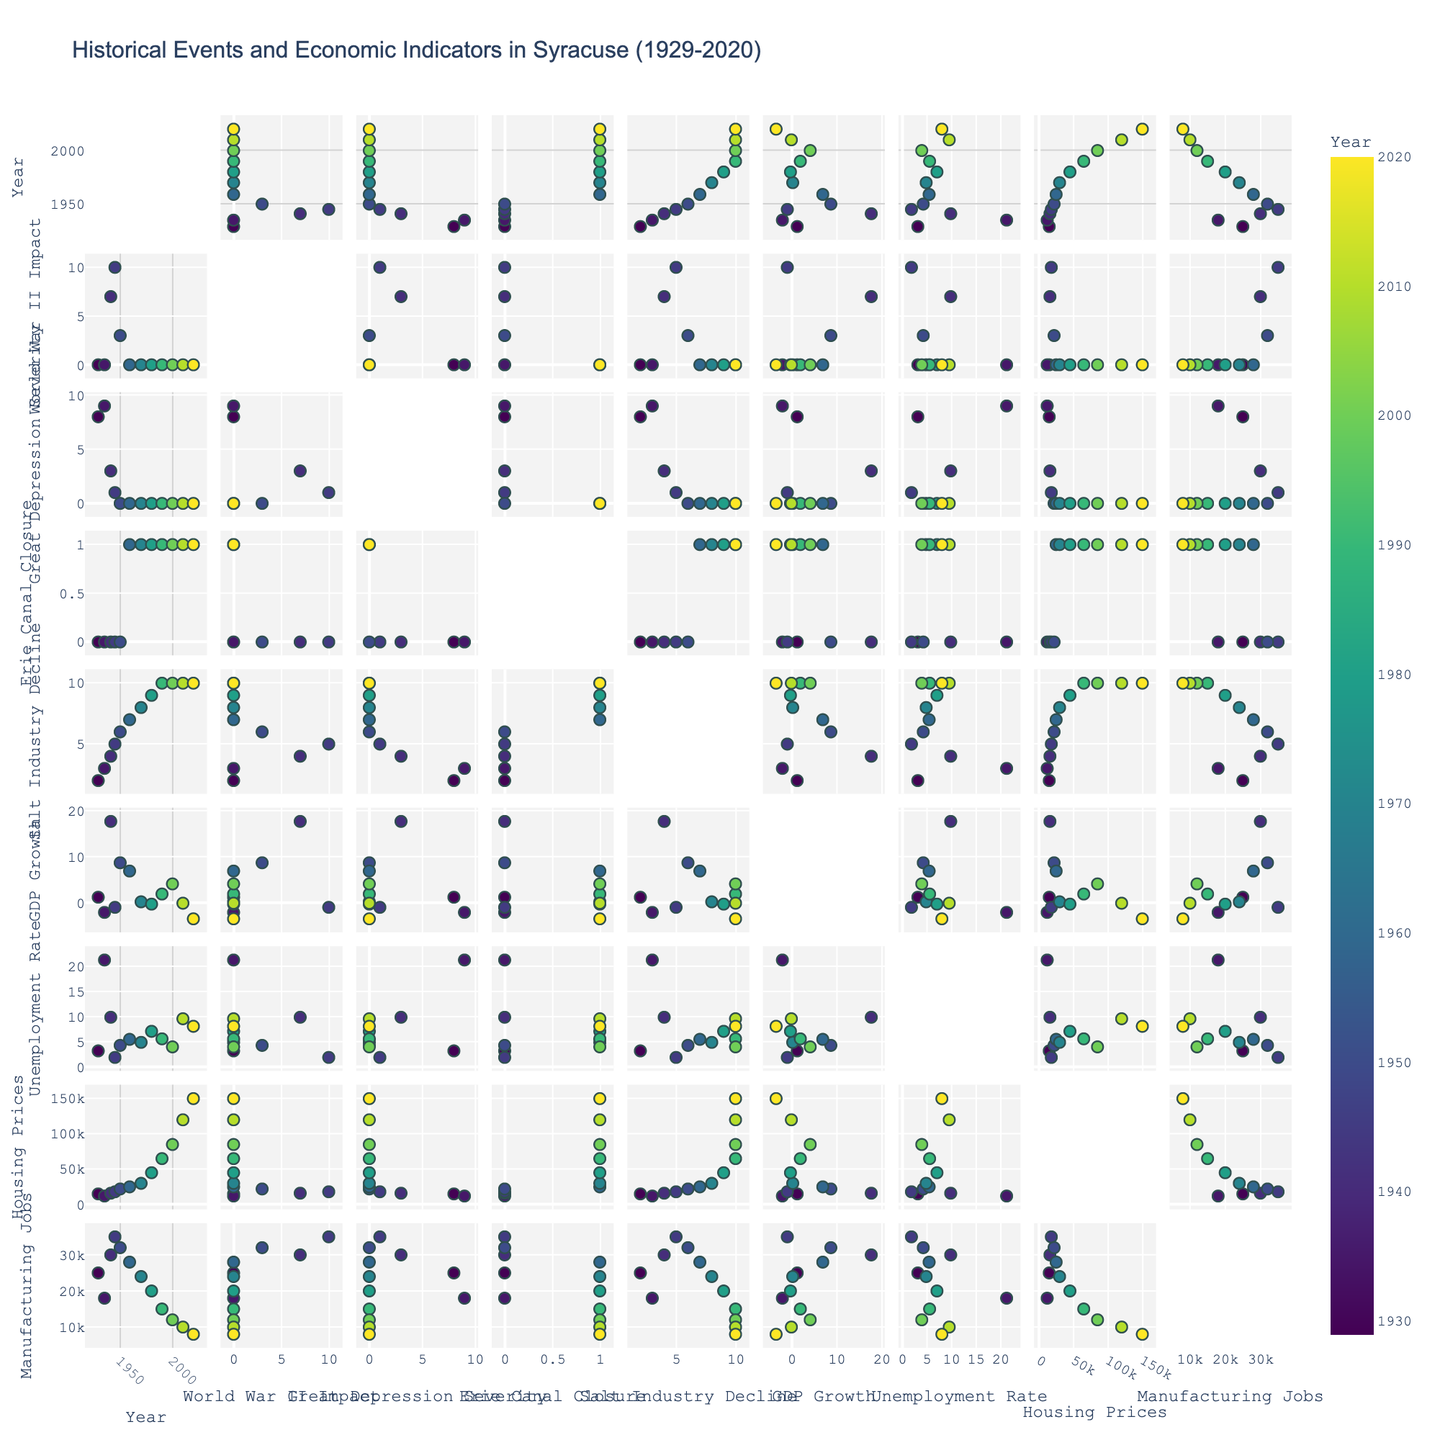Which historical event had the most significant immediate impact on GDP growth? By examining the scatterplot matrix, focus on the correlation between the World War II Impact and GDP Growth. The data point for the year corresponding to World War II (1941-1945) shows a significant spike in GDP growth during WWII.
Answer: World War II How did the Great Depression affect the unemployment rate in Syracuse? Look for the correlation between Great Depression Severity and Unemployment Rate. The years corresponding to the Great Depression (1929-1935) show notably high unemployment rates, peaking in 1935.
Answer: It caused a high unemployment rate, peaking in 1935 Compare the GDP growth between the closure of the Erie Canal and the decline of the salt industry. Which period shows a more substantial decline? Refer to the scatterplots between Erie Canal Closure, Salt Industry Decline, and GDP Growth. Compare the slopes and spread of the data points for the periods (1959 onwards for Erie Canal and increasing Salt Industry Decline). You will notice a more substantial decline in GDP Growth during the period associated with the Salt Industry's decline.
Answer: Salt Industry Decline How does the unemployment rate correlate with the Housing Prices in the dataset? Observe the scatterplot comparing Unemployment Rate and Housing Prices. A negative correlation is visible; as the unemployment rate decreases, housing prices generally increase.
Answer: Negative correlation Which year had the highest manufacturing jobs, and what were the contributing historical factors? Find the years on the scatterplot matrix showing Manufacturing Jobs and compare the values. The year 1945 shows the highest number of manufacturing jobs. It's linked to the end of WWII, where economic activities, including manufacturing, were at their peak due to war efforts.
Answer: 1945 due to WWII Was there an increase or decrease in Unemployment Rate from 1950 to 1980? Check the data points for the Unemployment Rate for the respective years. There is an increase in the Unemployment Rate from 4.3% in 1950 to 7.1% in 1980.
Answer: Increase Is there any visible correlation between Manufacturing Jobs and GDP Growth? Look at the scatterplot showing Manufacturing Jobs against GDP Growth. Notice the spread of data points; there appears to be no strong visible correlation between Manufacturing Jobs and GDP Growth.
Answer: No strong visible correlation During which historical event(s) did Housing Prices experience the most notable changes? Examine the scatterplot relating to significant spikes and dips in Housing Prices. Noticeable increase patterns can be found during the Salt Industry Decline (especially post-1970s).
Answer: Salt Industry Decline (post-1970s) How did the impact of World War II relate to the Great Depression Severity in terms of economic recovery indicators? Examine the scatterplot comparing World War II Impact and Great Depression Severity against economic indicators like GDP Growth and Unemployment Rate: a significant economic recovery is apparent post-World War II, indicating a major turn-around post-Great Depression.
Answer: Economic recovery post-World War II What is the trend in GDP Growth over the years, particularly focusing on the major events? Examine GDP Growth data points across the timeline: The highest positive spike corresponds to World War II, while significant declines can be observed during the Great Depression and the recent decade possibly reflecting economic crises.
Answer: Positive spike during WWII, declines during Great Depression and recent years 